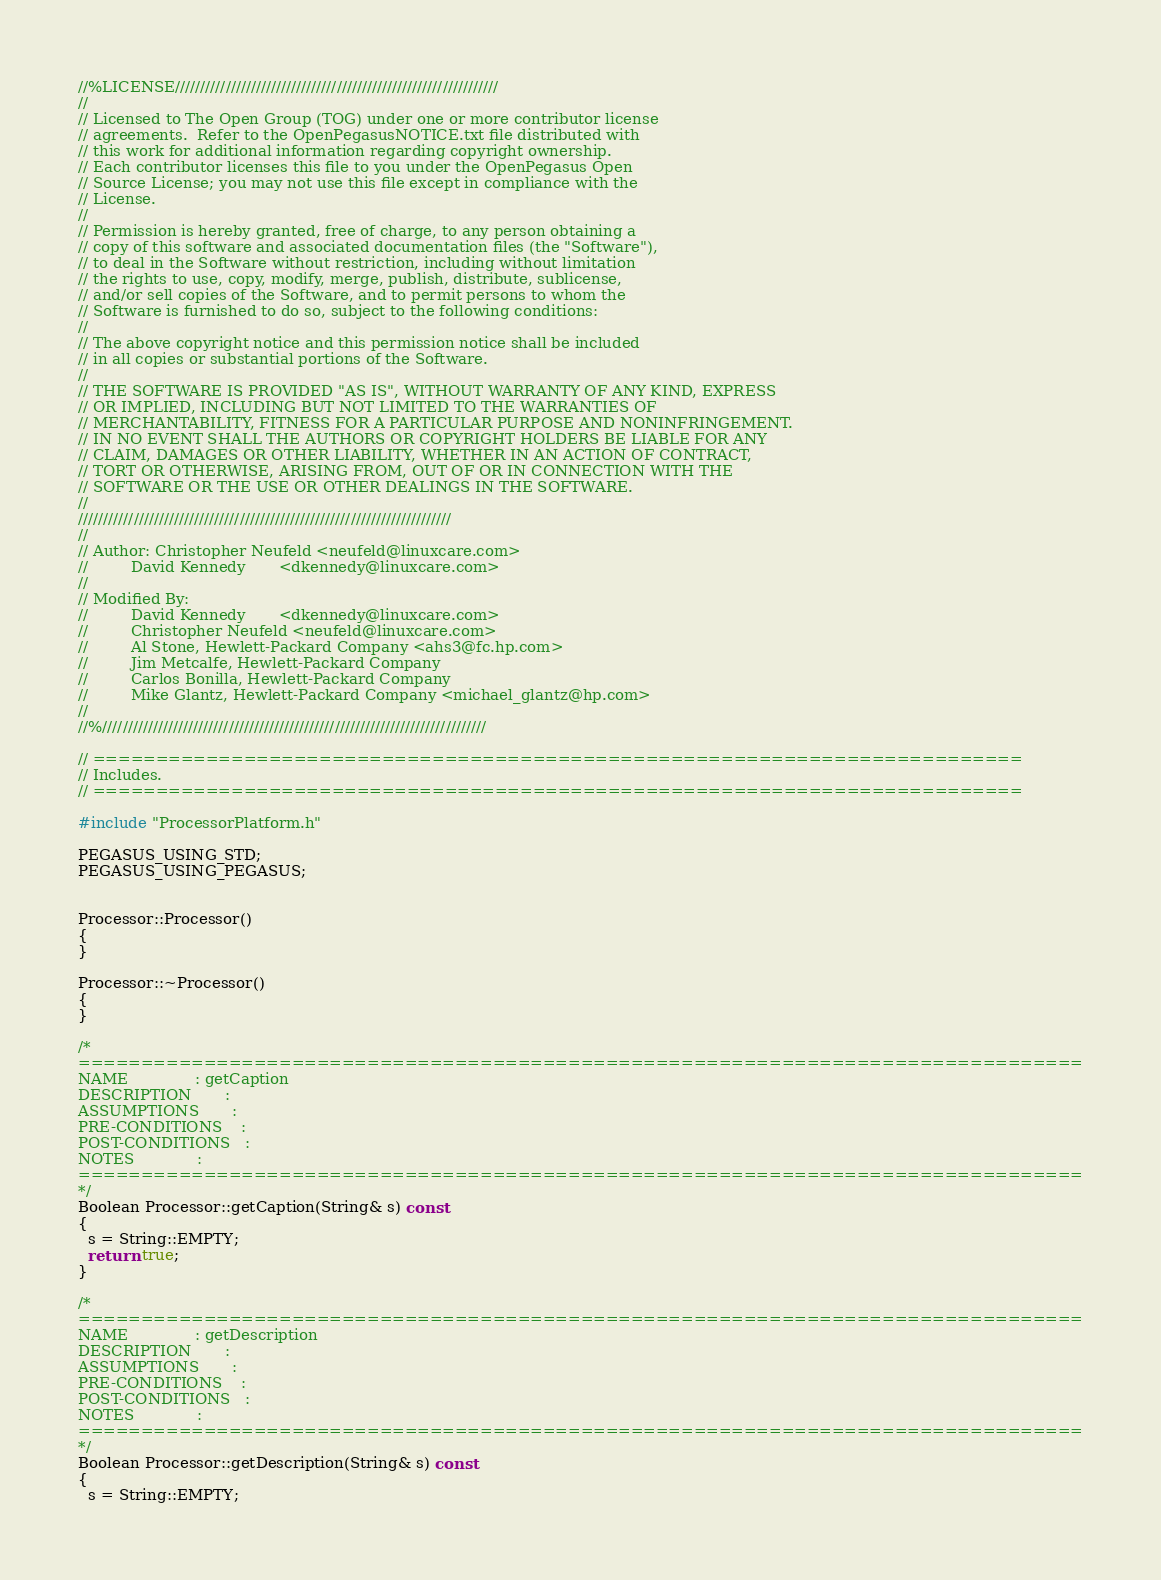Convert code to text. <code><loc_0><loc_0><loc_500><loc_500><_C++_>//%LICENSE////////////////////////////////////////////////////////////////
//
// Licensed to The Open Group (TOG) under one or more contributor license
// agreements.  Refer to the OpenPegasusNOTICE.txt file distributed with
// this work for additional information regarding copyright ownership.
// Each contributor licenses this file to you under the OpenPegasus Open
// Source License; you may not use this file except in compliance with the
// License.
//
// Permission is hereby granted, free of charge, to any person obtaining a
// copy of this software and associated documentation files (the "Software"),
// to deal in the Software without restriction, including without limitation
// the rights to use, copy, modify, merge, publish, distribute, sublicense,
// and/or sell copies of the Software, and to permit persons to whom the
// Software is furnished to do so, subject to the following conditions:
//
// The above copyright notice and this permission notice shall be included
// in all copies or substantial portions of the Software.
//
// THE SOFTWARE IS PROVIDED "AS IS", WITHOUT WARRANTY OF ANY KIND, EXPRESS
// OR IMPLIED, INCLUDING BUT NOT LIMITED TO THE WARRANTIES OF
// MERCHANTABILITY, FITNESS FOR A PARTICULAR PURPOSE AND NONINFRINGEMENT.
// IN NO EVENT SHALL THE AUTHORS OR COPYRIGHT HOLDERS BE LIABLE FOR ANY
// CLAIM, DAMAGES OR OTHER LIABILITY, WHETHER IN AN ACTION OF CONTRACT,
// TORT OR OTHERWISE, ARISING FROM, OUT OF OR IN CONNECTION WITH THE
// SOFTWARE OR THE USE OR OTHER DEALINGS IN THE SOFTWARE.
//
//////////////////////////////////////////////////////////////////////////
//
// Author: Christopher Neufeld <neufeld@linuxcare.com>
//         David Kennedy       <dkennedy@linuxcare.com>
//
// Modified By:
//         David Kennedy       <dkennedy@linuxcare.com>
//         Christopher Neufeld <neufeld@linuxcare.com>
//         Al Stone, Hewlett-Packard Company <ahs3@fc.hp.com>
//         Jim Metcalfe, Hewlett-Packard Company
//         Carlos Bonilla, Hewlett-Packard Company
//         Mike Glantz, Hewlett-Packard Company <michael_glantz@hp.com>
//
//%////////////////////////////////////////////////////////////////////////////

// ==========================================================================
// Includes.
// ==========================================================================

#include "ProcessorPlatform.h"

PEGASUS_USING_STD;
PEGASUS_USING_PEGASUS;


Processor::Processor()
{
}

Processor::~Processor()
{
}

/*
================================================================================
NAME              : getCaption
DESCRIPTION       :
ASSUMPTIONS       :
PRE-CONDITIONS    :
POST-CONDITIONS   :
NOTES             :
================================================================================
*/
Boolean Processor::getCaption(String& s) const
{
  s = String::EMPTY;
  return true;
}

/*
================================================================================
NAME              : getDescription
DESCRIPTION       :
ASSUMPTIONS       :
PRE-CONDITIONS    :
POST-CONDITIONS   :
NOTES             :
================================================================================
*/
Boolean Processor::getDescription(String& s) const
{
  s = String::EMPTY;</code> 